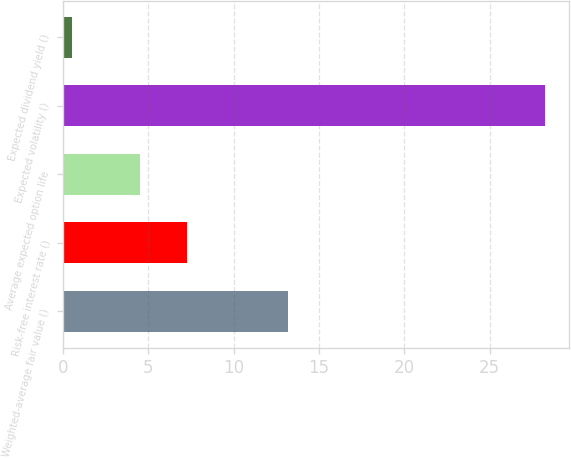<chart> <loc_0><loc_0><loc_500><loc_500><bar_chart><fcel>Weighted-average fair value ()<fcel>Risk-free interest rate ()<fcel>Average expected option life<fcel>Expected volatility ()<fcel>Expected dividend yield ()<nl><fcel>13.19<fcel>7.28<fcel>4.51<fcel>28.24<fcel>0.54<nl></chart> 